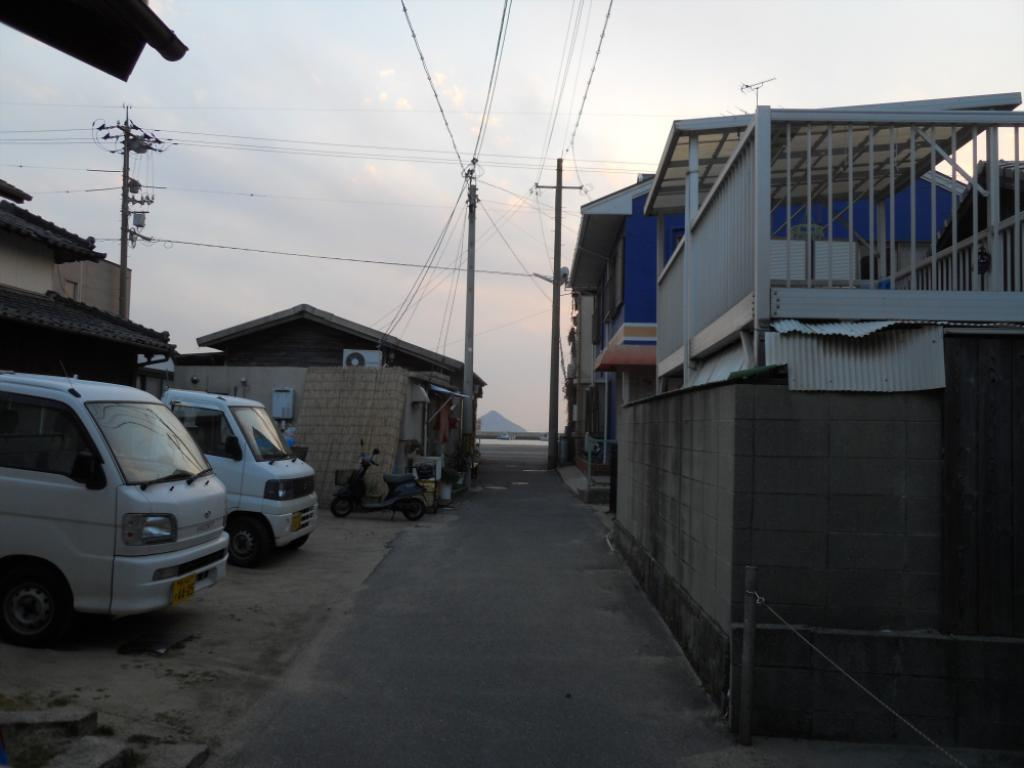What type of structures can be seen in the image? There are buildings in the image. What else is present in the image besides buildings? There are vehicles, a road, poles, and wires visible in the image. Can you describe the road in the image? The road is visible in the image. What is visible at the top of the image? The sky is visible at the top of the image. What type of scent can be detected from the field in the image? There is no field present in the image; it features buildings, vehicles, a road, poles, wires, and the sky. What kind of pets are visible in the image? There are no pets visible in the image. 